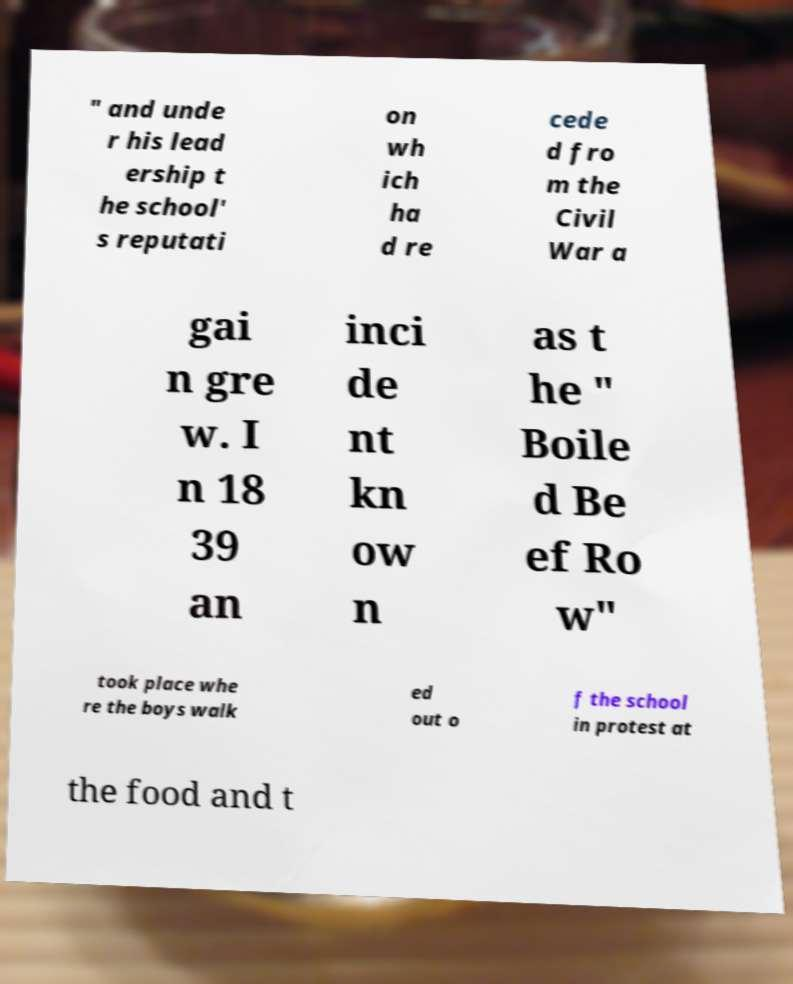Could you extract and type out the text from this image? " and unde r his lead ership t he school' s reputati on wh ich ha d re cede d fro m the Civil War a gai n gre w. I n 18 39 an inci de nt kn ow n as t he " Boile d Be ef Ro w" took place whe re the boys walk ed out o f the school in protest at the food and t 